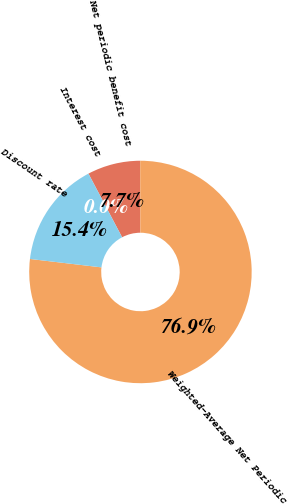Convert chart. <chart><loc_0><loc_0><loc_500><loc_500><pie_chart><fcel>Interest cost<fcel>Net periodic benefit cost<fcel>Weighted-Average Net Periodic<fcel>Discount rate<nl><fcel>0.01%<fcel>7.7%<fcel>76.9%<fcel>15.39%<nl></chart> 